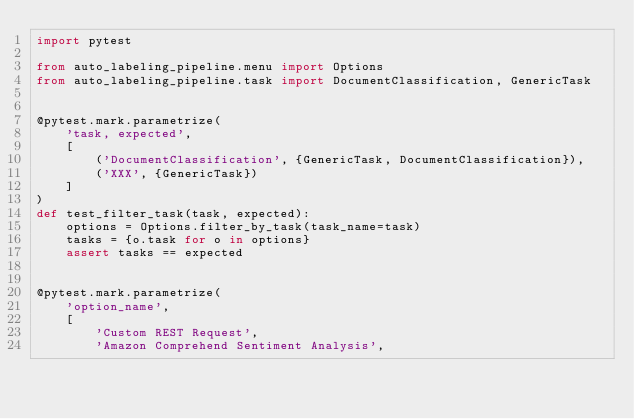<code> <loc_0><loc_0><loc_500><loc_500><_Python_>import pytest

from auto_labeling_pipeline.menu import Options
from auto_labeling_pipeline.task import DocumentClassification, GenericTask


@pytest.mark.parametrize(
    'task, expected',
    [
        ('DocumentClassification', {GenericTask, DocumentClassification}),
        ('XXX', {GenericTask})
    ]
)
def test_filter_task(task, expected):
    options = Options.filter_by_task(task_name=task)
    tasks = {o.task for o in options}
    assert tasks == expected


@pytest.mark.parametrize(
    'option_name',
    [
        'Custom REST Request',
        'Amazon Comprehend Sentiment Analysis',</code> 